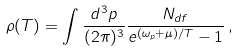Convert formula to latex. <formula><loc_0><loc_0><loc_500><loc_500>\rho ( T ) = \int \frac { d ^ { 3 } { p } } { ( 2 \pi ) ^ { 3 } } \frac { N _ { d f } } { e ^ { ( \omega _ { p } + \mu ) / T } - 1 } \, ,</formula> 